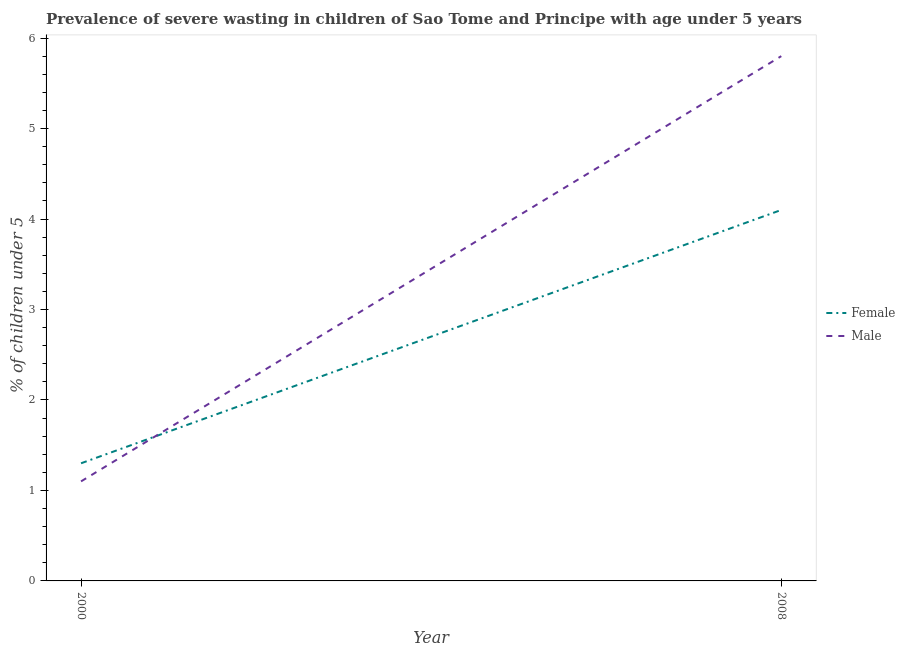How many different coloured lines are there?
Offer a terse response. 2. Does the line corresponding to percentage of undernourished female children intersect with the line corresponding to percentage of undernourished male children?
Your response must be concise. Yes. Is the number of lines equal to the number of legend labels?
Offer a very short reply. Yes. What is the percentage of undernourished male children in 2000?
Offer a terse response. 1.1. Across all years, what is the maximum percentage of undernourished male children?
Your answer should be very brief. 5.8. Across all years, what is the minimum percentage of undernourished male children?
Provide a short and direct response. 1.1. What is the total percentage of undernourished male children in the graph?
Offer a terse response. 6.9. What is the difference between the percentage of undernourished male children in 2000 and that in 2008?
Offer a terse response. -4.7. What is the difference between the percentage of undernourished male children in 2008 and the percentage of undernourished female children in 2000?
Give a very brief answer. 4.5. What is the average percentage of undernourished female children per year?
Offer a terse response. 2.7. In the year 2008, what is the difference between the percentage of undernourished female children and percentage of undernourished male children?
Offer a very short reply. -1.7. In how many years, is the percentage of undernourished female children greater than 0.2 %?
Provide a short and direct response. 2. What is the ratio of the percentage of undernourished female children in 2000 to that in 2008?
Make the answer very short. 0.32. Is the percentage of undernourished female children in 2000 less than that in 2008?
Offer a very short reply. Yes. Does the percentage of undernourished male children monotonically increase over the years?
Offer a terse response. Yes. Is the percentage of undernourished male children strictly greater than the percentage of undernourished female children over the years?
Your response must be concise. No. What is the difference between two consecutive major ticks on the Y-axis?
Your response must be concise. 1. What is the title of the graph?
Offer a terse response. Prevalence of severe wasting in children of Sao Tome and Principe with age under 5 years. Does "Residents" appear as one of the legend labels in the graph?
Your answer should be compact. No. What is the label or title of the Y-axis?
Your answer should be compact.  % of children under 5. What is the  % of children under 5 in Female in 2000?
Offer a terse response. 1.3. What is the  % of children under 5 in Male in 2000?
Make the answer very short. 1.1. What is the  % of children under 5 in Female in 2008?
Ensure brevity in your answer.  4.1. What is the  % of children under 5 in Male in 2008?
Provide a succinct answer. 5.8. Across all years, what is the maximum  % of children under 5 of Female?
Offer a terse response. 4.1. Across all years, what is the maximum  % of children under 5 in Male?
Offer a very short reply. 5.8. Across all years, what is the minimum  % of children under 5 in Female?
Provide a short and direct response. 1.3. Across all years, what is the minimum  % of children under 5 of Male?
Ensure brevity in your answer.  1.1. What is the total  % of children under 5 of Male in the graph?
Ensure brevity in your answer.  6.9. What is the difference between the  % of children under 5 of Male in 2000 and that in 2008?
Give a very brief answer. -4.7. What is the difference between the  % of children under 5 in Female in 2000 and the  % of children under 5 in Male in 2008?
Keep it short and to the point. -4.5. What is the average  % of children under 5 of Male per year?
Ensure brevity in your answer.  3.45. What is the ratio of the  % of children under 5 in Female in 2000 to that in 2008?
Give a very brief answer. 0.32. What is the ratio of the  % of children under 5 in Male in 2000 to that in 2008?
Your answer should be compact. 0.19. What is the difference between the highest and the second highest  % of children under 5 of Female?
Keep it short and to the point. 2.8. What is the difference between the highest and the lowest  % of children under 5 in Female?
Your answer should be very brief. 2.8. 